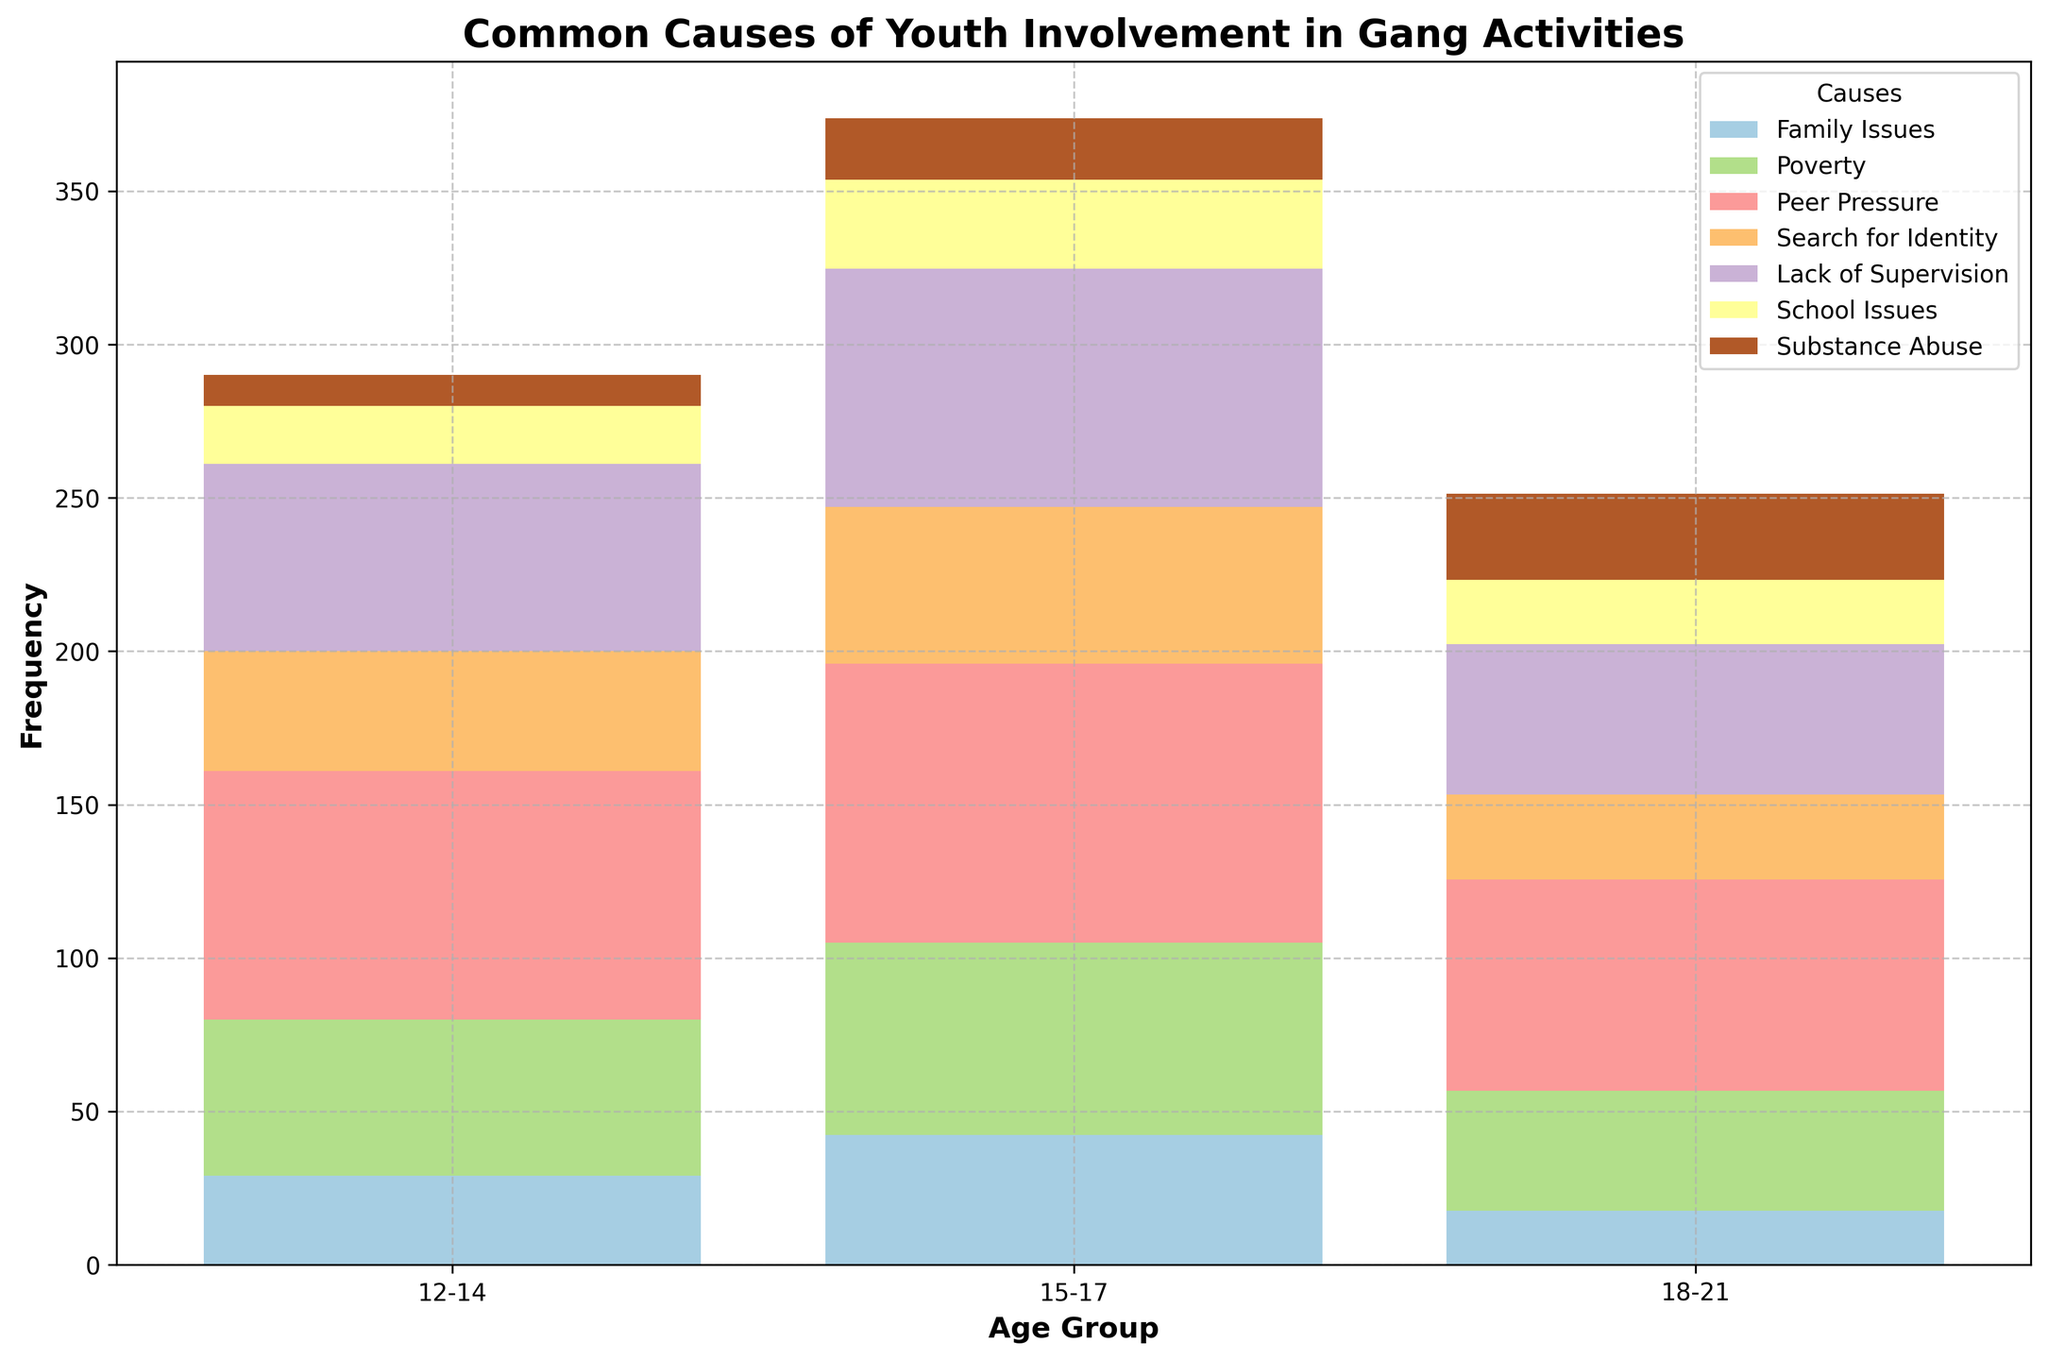What's the most common cause of youth involvement in gang activities for the age group 15-17? The tallest bar in the age group 15-17 category represents the highest frequency. For the age group 15-17, Peer Pressure has the highest frequency.
Answer: Peer Pressure Which age group has the highest involvement due to Family Issues? Compare the heights of the bars corresponding to Family Issues across all age groups. The age group 15-17 has the highest bar for Family Issues.
Answer: 15-17 Is the frequency of Poverty-related involvement higher in the age group 12-14 or 18-21? Compare the height of the bars corresponding to Poverty in the age groups 12-14 and 18-21. The bar for 12-14 is higher than that for 18-21.
Answer: 12-14 Which cause shows an increased trend as age progresses from 12-14 to 18-21? Track the heights of the bars related to each cause across the age groups. Substance Abuse is the only cause increasing as age progresses from 12-14 to 18-21.
Answer: Substance Abuse What's the average frequency of Lack of Supervision-related involvement for all age groups? Calculate the average by adding up the frequencies for Lack of Supervision for each age group and dividing by the number of age groups (60 + 80 + 50 + 65 + 75 + 45 + 58 + 78 + 52) / 3 = 63.67
Answer: 63.67 Compare the total frequency of School Issues and Search for Identity in the age group 15-17. Which one is higher? Add up the frequencies for School Issues and Search for Identity for the age group 15-17. School Issues: (30 + 25 + 32) = 90, Search for Identity: (50 + 55 + 48) = 93. So, Search for Identity is higher.
Answer: Search for Identity What is the least common cause of gang involvement for the age group 18-21? The shortest bar in the age group 18-21 represents the lowest frequency. Family Issues have the lowest frequency for the age group 18-21.
Answer: Family Issues Compare the frequency of Peer Pressure and Substance Abuse among the age group 12-14. Which one has a higher frequency? Compare the heights of the bars corresponding to Peer Pressure and Substance Abuse in the age group 12-14. Peer Pressure has a significantly higher bar.
Answer: Peer Pressure What’s the difference in frequency of involvement due to Family Issues between the age group 12-14 and 15-17? The frequency of Family Issues in age groups 12-14 and 15-17 are 30 and 40 respectively. The difference is 40 - 30 = 10.
Answer: 10 What causes have the same frequency in the 12-14 age group? Identify bars with the same height for the 12-14 age group. The exact heights should be matched. None of the causes have the same frequency exactly.
Answer: None 